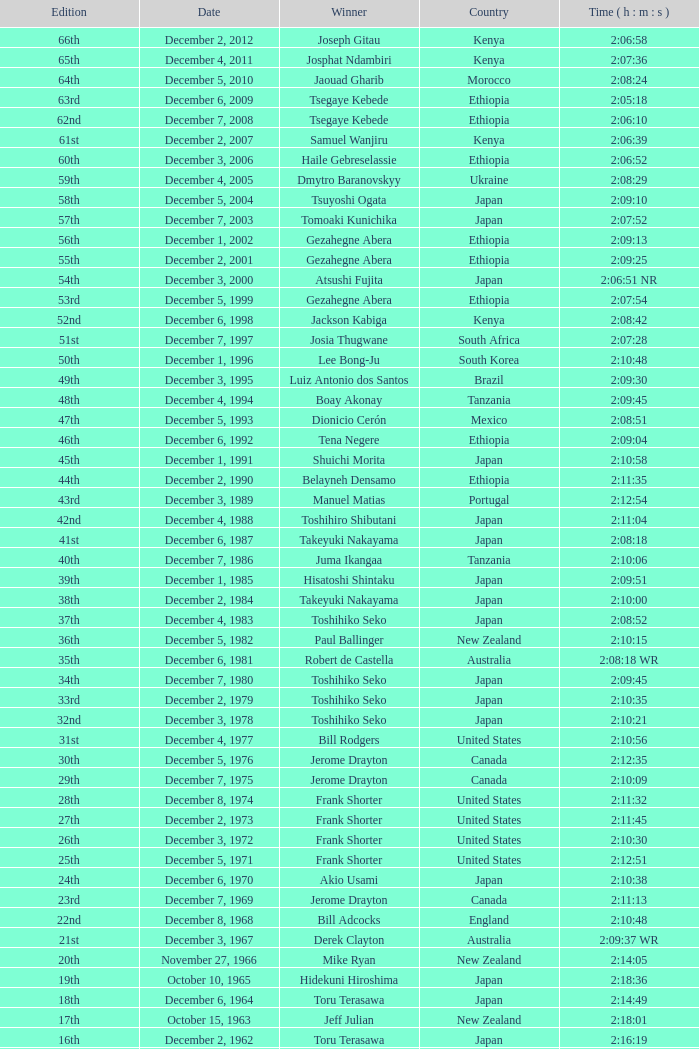Which country does the victor of the 20th edition come from? New Zealand. 